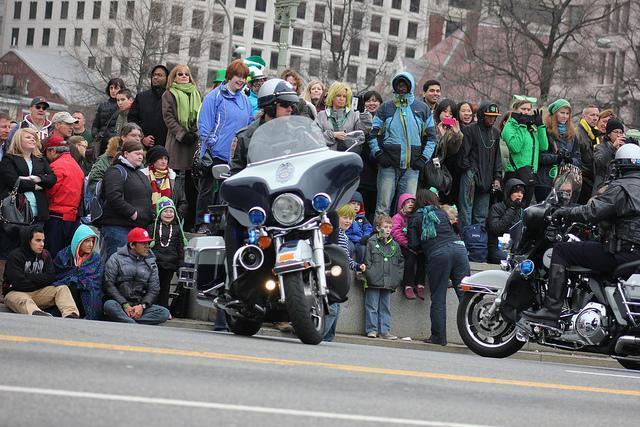How many motorcycles are visible?
Give a very brief answer. 2. How many people are there?
Give a very brief answer. 9. 